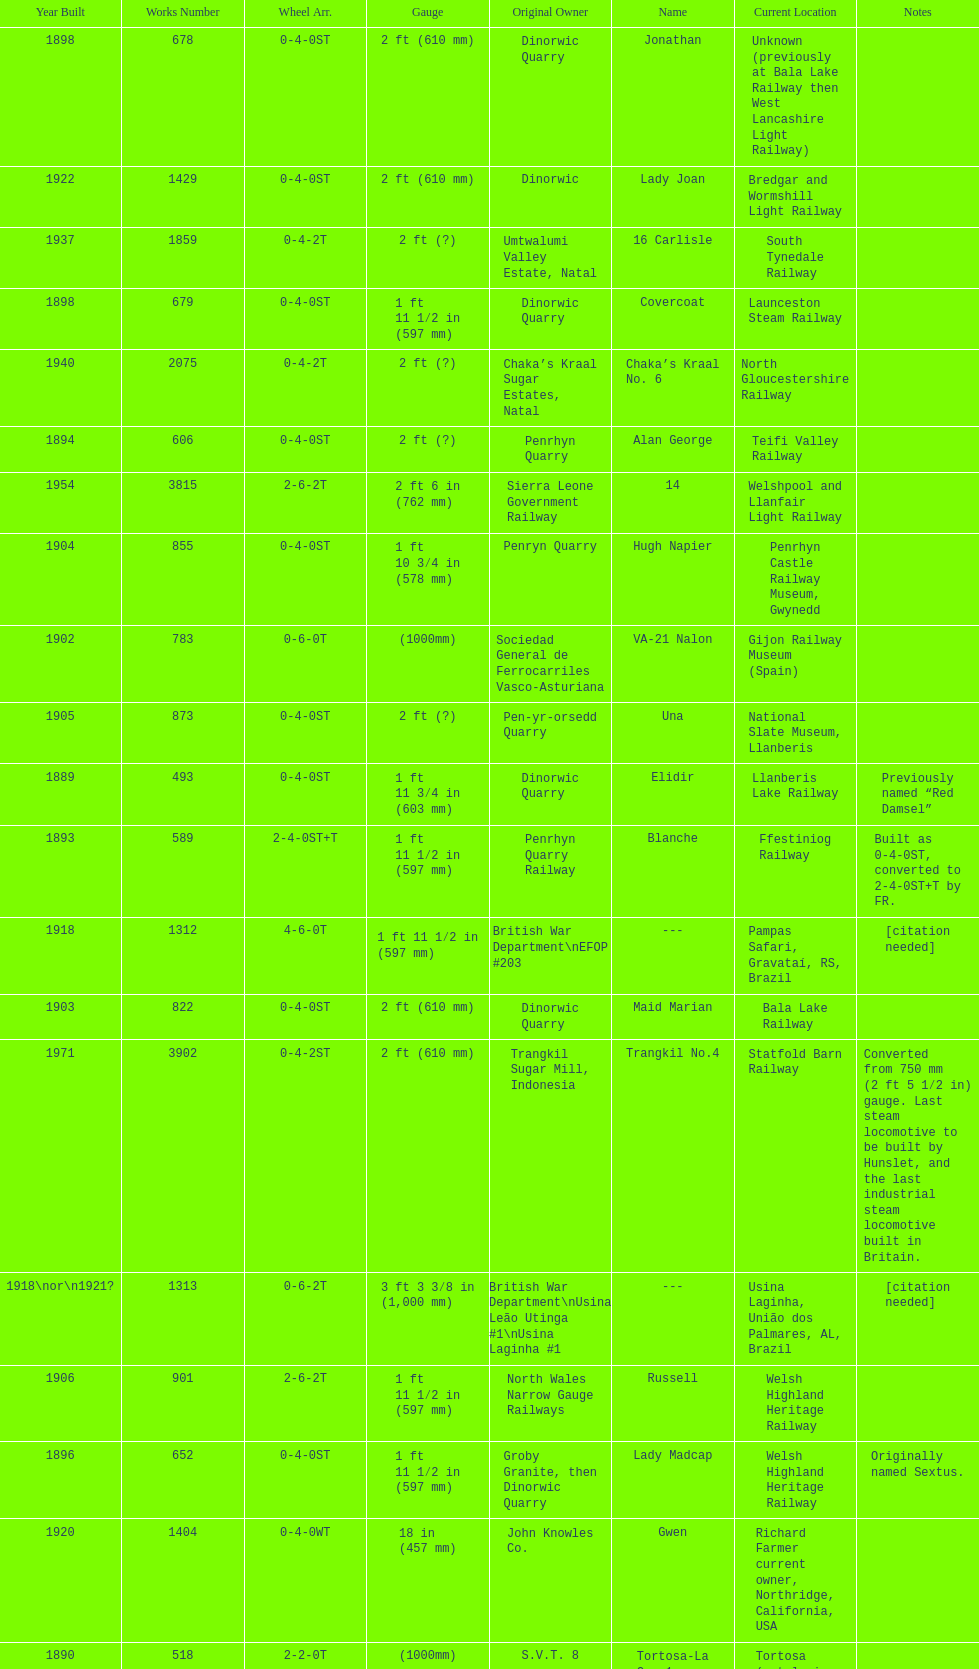After 1940, how many steam locomotives were built? 2. Could you help me parse every detail presented in this table? {'header': ['Year Built', 'Works Number', 'Wheel Arr.', 'Gauge', 'Original Owner', 'Name', 'Current Location', 'Notes'], 'rows': [['1898', '678', '0-4-0ST', '2\xa0ft (610\xa0mm)', 'Dinorwic Quarry', 'Jonathan', 'Unknown (previously at Bala Lake Railway then West Lancashire Light Railway)', ''], ['1922', '1429', '0-4-0ST', '2\xa0ft (610\xa0mm)', 'Dinorwic', 'Lady Joan', 'Bredgar and Wormshill Light Railway', ''], ['1937', '1859', '0-4-2T', '2\xa0ft (?)', 'Umtwalumi Valley Estate, Natal', '16 Carlisle', 'South Tynedale Railway', ''], ['1898', '679', '0-4-0ST', '1\xa0ft 11\xa01⁄2\xa0in (597\xa0mm)', 'Dinorwic Quarry', 'Covercoat', 'Launceston Steam Railway', ''], ['1940', '2075', '0-4-2T', '2\xa0ft (?)', 'Chaka’s Kraal Sugar Estates, Natal', 'Chaka’s Kraal No. 6', 'North Gloucestershire Railway', ''], ['1894', '606', '0-4-0ST', '2\xa0ft (?)', 'Penrhyn Quarry', 'Alan George', 'Teifi Valley Railway', ''], ['1954', '3815', '2-6-2T', '2\xa0ft 6\xa0in (762\xa0mm)', 'Sierra Leone Government Railway', '14', 'Welshpool and Llanfair Light Railway', ''], ['1904', '855', '0-4-0ST', '1\xa0ft 10\xa03⁄4\xa0in (578\xa0mm)', 'Penryn Quarry', 'Hugh Napier', 'Penrhyn Castle Railway Museum, Gwynedd', ''], ['1902', '783', '0-6-0T', '(1000mm)', 'Sociedad General de Ferrocarriles Vasco-Asturiana', 'VA-21 Nalon', 'Gijon Railway Museum (Spain)', ''], ['1905', '873', '0-4-0ST', '2\xa0ft (?)', 'Pen-yr-orsedd Quarry', 'Una', 'National Slate Museum, Llanberis', ''], ['1889', '493', '0-4-0ST', '1\xa0ft 11\xa03⁄4\xa0in (603\xa0mm)', 'Dinorwic Quarry', 'Elidir', 'Llanberis Lake Railway', 'Previously named “Red Damsel”'], ['1893', '589', '2-4-0ST+T', '1\xa0ft 11\xa01⁄2\xa0in (597\xa0mm)', 'Penrhyn Quarry Railway', 'Blanche', 'Ffestiniog Railway', 'Built as 0-4-0ST, converted to 2-4-0ST+T by FR.'], ['1918', '1312', '4-6-0T', '1\xa0ft\xa011\xa01⁄2\xa0in (597\xa0mm)', 'British War Department\\nEFOP #203', '---', 'Pampas Safari, Gravataí, RS, Brazil', '[citation needed]'], ['1903', '822', '0-4-0ST', '2\xa0ft (610\xa0mm)', 'Dinorwic Quarry', 'Maid Marian', 'Bala Lake Railway', ''], ['1971', '3902', '0-4-2ST', '2\xa0ft (610\xa0mm)', 'Trangkil Sugar Mill, Indonesia', 'Trangkil No.4', 'Statfold Barn Railway', 'Converted from 750\xa0mm (2\xa0ft\xa05\xa01⁄2\xa0in) gauge. Last steam locomotive to be built by Hunslet, and the last industrial steam locomotive built in Britain.'], ['1918\\nor\\n1921?', '1313', '0-6-2T', '3\xa0ft\xa03\xa03⁄8\xa0in (1,000\xa0mm)', 'British War Department\\nUsina Leão Utinga #1\\nUsina Laginha #1', '---', 'Usina Laginha, União dos Palmares, AL, Brazil', '[citation needed]'], ['1906', '901', '2-6-2T', '1\xa0ft 11\xa01⁄2\xa0in (597\xa0mm)', 'North Wales Narrow Gauge Railways', 'Russell', 'Welsh Highland Heritage Railway', ''], ['1896', '652', '0-4-0ST', '1\xa0ft 11\xa01⁄2\xa0in (597\xa0mm)', 'Groby Granite, then Dinorwic Quarry', 'Lady Madcap', 'Welsh Highland Heritage Railway', 'Originally named Sextus.'], ['1920', '1404', '0-4-0WT', '18\xa0in (457\xa0mm)', 'John Knowles Co.', 'Gwen', 'Richard Farmer current owner, Northridge, California, USA', ''], ['1890', '518', '2-2-0T', '(1000mm)', 'S.V.T. 8', 'Tortosa-La Cava1', 'Tortosa (catalonia, Spain)', ''], ['1902', '779', '0-4-0ST', '2\xa0ft (610\xa0mm)', 'Dinorwic Quarry', 'Holy War', 'Bala Lake Railway', ''], ['1886', '409', '0-4-0ST', '1\xa0ft 11\xa01⁄2\xa0in (597\xa0mm)', 'Dinorwic Quarry', 'Velinheli', 'Launceston Steam Railway', ''], ['1891', '542', '0-4-0ST', '2\xa0ft (610\xa0mm)', 'Dinorwic Quarry', 'Cloister', 'Purbeck Mineral & Mining Museum', 'Owned by Hampshire Narrow Gauge Railway Trust, previously at Kew Bridge Steam Museum and Amberley'], ['1909', '994', '0-4-0ST', '2\xa0ft (?)', 'Penrhyn Quarry', 'Bill Harvey', 'Bressingham Steam Museum', 'previously George Sholto'], ['1922', '1430', '0-4-0ST', '1\xa0ft 11\xa03⁄4\xa0in (603\xa0mm)', 'Dinorwic Quarry', 'Dolbadarn', 'Llanberis Lake Railway', ''], ['1899', '705', '0-4-0ST', '2\xa0ft (610\xa0mm)', 'Penrhyn Quarry', 'Elin', 'Yaxham Light Railway', 'Previously at the Lincolnshire Coast Light Railway.'], ['1883', '316', '0-4-0ST', '2\xa0ft (?)', 'Penrhyn Quarry', 'Gwynedd', 'Bressingham Steam Museum', 'Penrhyn Port Class'], ['1883', '317', '0-4-0ST', '1\xa0ft 11\xa01⁄2\xa0in (597\xa0mm)', 'Penrhyn Quarry', 'Lilian', 'Launceston Steam Railway', 'Penrhyn Port Class'], ['1891', '541', '0-4-0ST', '1\xa0ft 10\xa03⁄4\xa0in (578\xa0mm)', 'Dinorwic Quarry', 'Rough Pup', 'Narrow Gauge Railway Museum, Tywyn', ''], ['1902', '780', '0-4-0ST', '2\xa0ft (610\xa0mm)', 'Dinorwic Quarry', 'Alice', 'Bala Lake Railway', ''], ['1898', '684', '0-4-0WT', '18\xa0in (457\xa0mm)', 'John Knowles Co.', 'Jack', 'Armley Mills Industrial Museum, Leeds', ''], ['1901', '763', '0-4-0ST', '1\xa0ft 11\xa01⁄2\xa0in (597\xa0mm)', 'Dorothea Quarry', 'Dorothea', 'Launceston Steam Railway', ''], ['1895', '638', '0-4-0ST', '2\xa0ft (610\xa0mm)', 'Dinorwic', 'Jerry M', 'Hollycombe Steam Collection', ''], ['1894', '605', '0-4-0ST', '1\xa0ft 11\xa03⁄4\xa0in (603\xa0mm)', 'Penrhyn Quarry', 'Margaret', 'Vale of Rheidol Railway', 'Under restoration.[citation needed]'], ['1903', '827', '0-4-0ST', '1\xa0ft 11\xa03⁄4\xa0in (603\xa0mm)', 'Pen-yr-orsedd Quarry', 'Sybil', 'Brecon Mountain Railway', ''], ['1906', '920', '0-4-0ST', '2\xa0ft (?)', 'Penrhyn Quarry', 'Pamela', 'Old Kiln Light Railway', ''], ['1904', '894', '0-4-0ST', '1\xa0ft 11\xa03⁄4\xa0in (603\xa0mm)', 'Dinorwic Quarry', 'Thomas Bach', 'Llanberis Lake Railway', 'Originally named “Wild Aster”'], ['1899', '707', '0-4-0ST', '1\xa0ft 11\xa01⁄2\xa0in (597\xa0mm)', 'Pen-yr-orsedd Quarry', 'Britomart', 'Ffestiniog Railway', ''], ['1893', '590', '2-4-0ST+T', '1\xa0ft 11\xa01⁄2\xa0in (597\xa0mm)', 'Penrhyn Quarry Railway', 'Linda', 'Ffestiniog Railway', 'Built as 0-4-0ST, converted to 2-4-0ST+T by FR.'], ['1891', '554', '0-4-0ST', '1\xa0ft 11\xa01⁄2\xa0in (597\xa0mm)', 'Cilgwyn quarry, then Penrhyn Quarry Railway', 'Lilla', 'Ffestiniog Railway', ''], ['1885', '364', '0-4-0ST', '22.75', 'Penrhyn Quarry', 'Winifred', 'Bala Lake Railway', 'Penrhyn Port Class'], ['1898', '680', '0-4-0ST', '2\xa0ft (610\xa0mm)', 'Dinorwic Quarry', 'George B', 'Bala Lake Railway', ''], ['1903', '823', '0-4-0ST', '2\xa0ft (?)', 'Dinorwic Quarry', 'Irish Mail', 'West Lancashire Light Railway', ''], ['1882', '283', '0-4-0ST', '1\xa0ft 10\xa03⁄4\xa0in (578\xa0mm)', 'Penrhyn Quarry', 'Charles', 'Penrhyn Castle Railway Museum', '']]} 